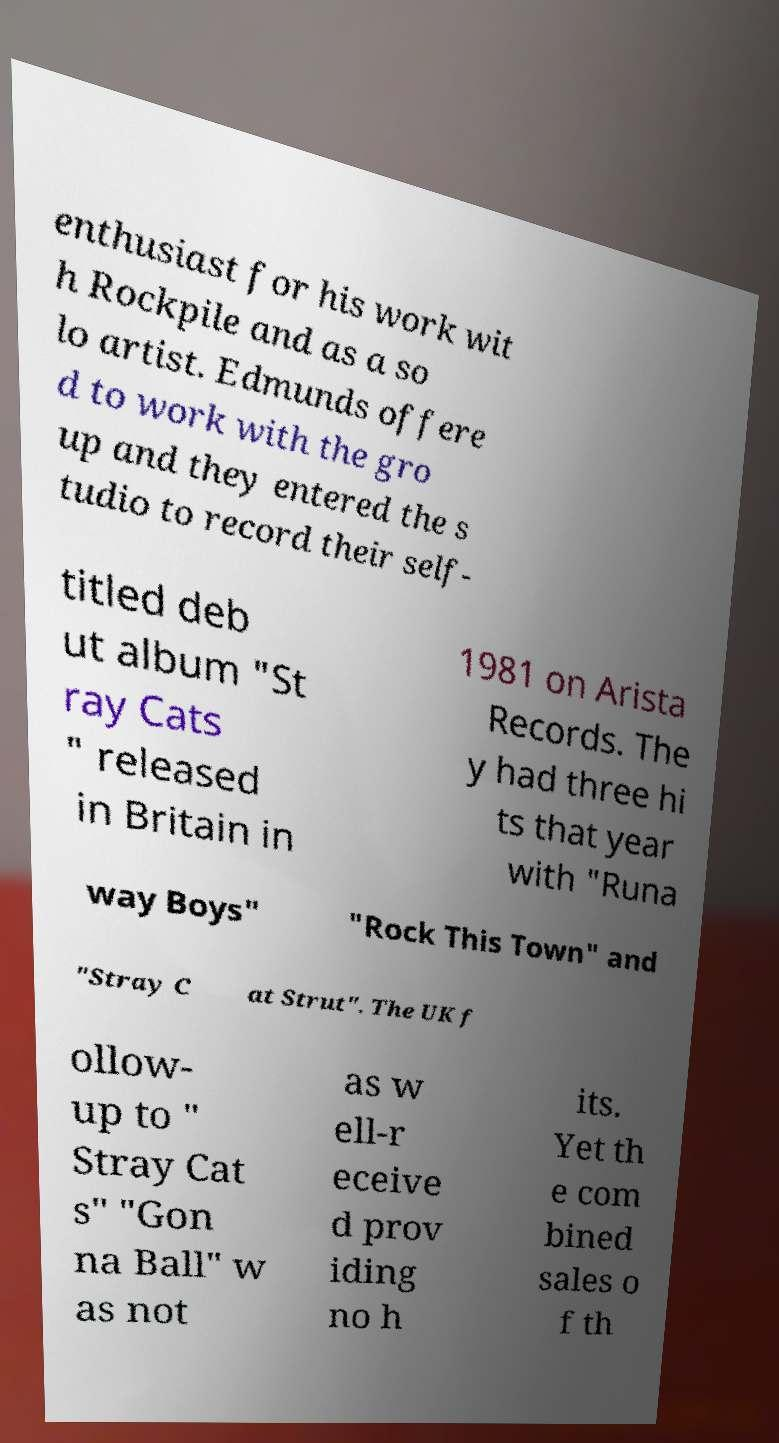Can you accurately transcribe the text from the provided image for me? enthusiast for his work wit h Rockpile and as a so lo artist. Edmunds offere d to work with the gro up and they entered the s tudio to record their self- titled deb ut album "St ray Cats " released in Britain in 1981 on Arista Records. The y had three hi ts that year with "Runa way Boys" "Rock This Town" and "Stray C at Strut". The UK f ollow- up to " Stray Cat s" "Gon na Ball" w as not as w ell-r eceive d prov iding no h its. Yet th e com bined sales o f th 